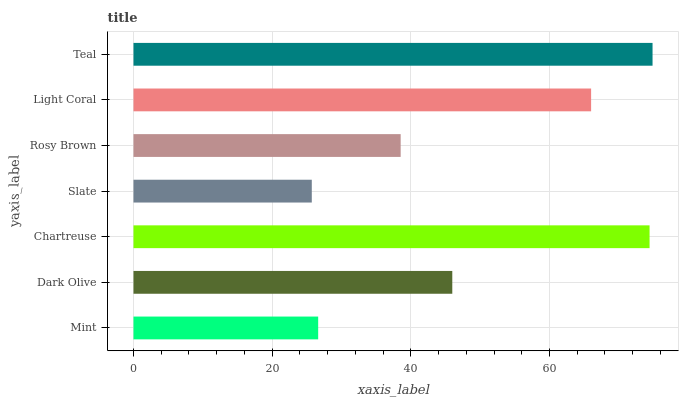Is Slate the minimum?
Answer yes or no. Yes. Is Teal the maximum?
Answer yes or no. Yes. Is Dark Olive the minimum?
Answer yes or no. No. Is Dark Olive the maximum?
Answer yes or no. No. Is Dark Olive greater than Mint?
Answer yes or no. Yes. Is Mint less than Dark Olive?
Answer yes or no. Yes. Is Mint greater than Dark Olive?
Answer yes or no. No. Is Dark Olive less than Mint?
Answer yes or no. No. Is Dark Olive the high median?
Answer yes or no. Yes. Is Dark Olive the low median?
Answer yes or no. Yes. Is Teal the high median?
Answer yes or no. No. Is Rosy Brown the low median?
Answer yes or no. No. 